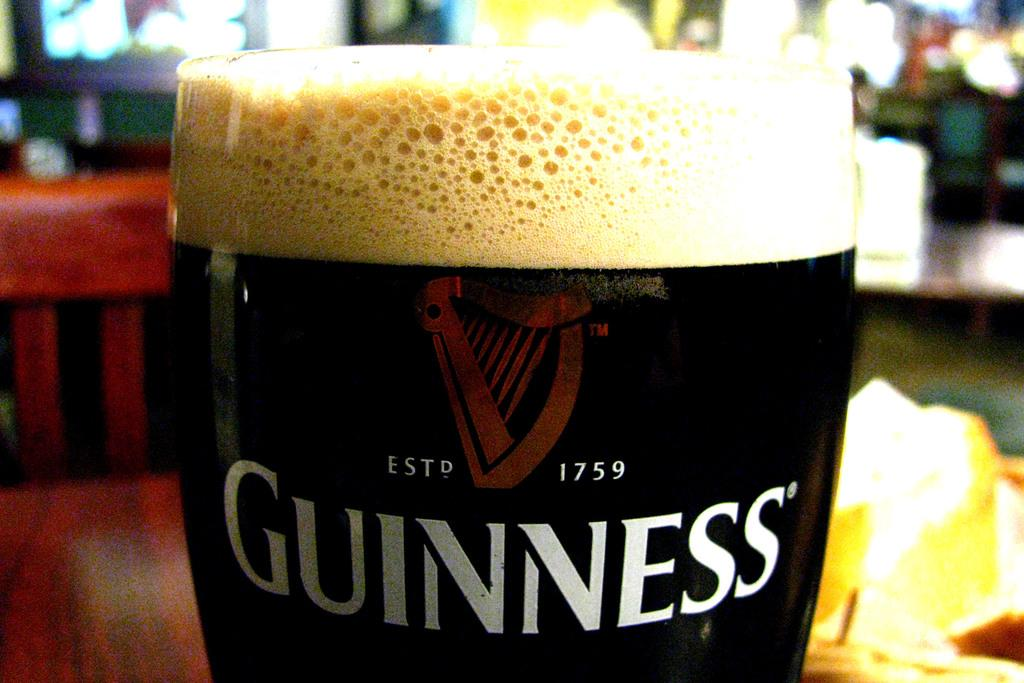Provide a one-sentence caption for the provided image. A glass of Guinness beer sitting on a restaurant table. 